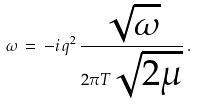Convert formula to latex. <formula><loc_0><loc_0><loc_500><loc_500>\omega \, = \, - i \, q ^ { 2 } \, \frac { \sqrt { \omega } } { 2 \pi T \sqrt { 2 \mu } } \, .</formula> 